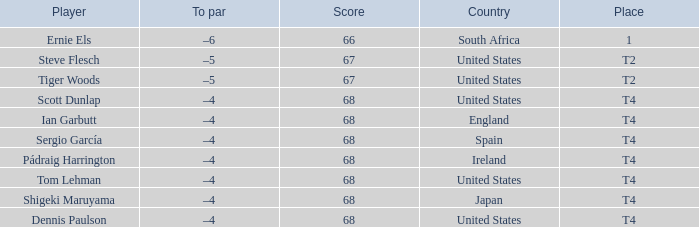What is the Place of the Player with a Score of 67? T2, T2. 